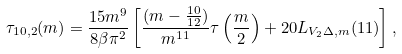<formula> <loc_0><loc_0><loc_500><loc_500>\tau _ { 1 0 , 2 } ( m ) = \frac { 1 5 m ^ { 9 } } { 8 \beta \pi ^ { 2 } } \left [ \frac { ( m - \frac { 1 0 } { 1 2 } ) } { m ^ { 1 1 } } \tau \left ( \frac { m } { 2 } \right ) + 2 0 L _ { V _ { 2 } \Delta , m } ( 1 1 ) \right ] ,</formula> 